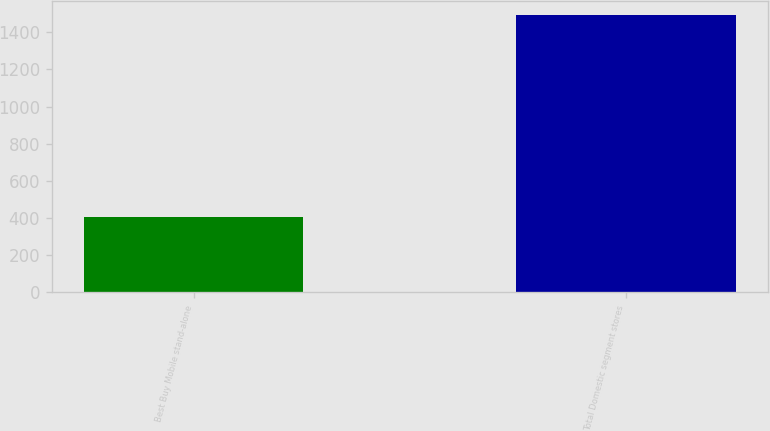Convert chart. <chart><loc_0><loc_0><loc_500><loc_500><bar_chart><fcel>Best Buy Mobile stand-alone<fcel>Total Domestic segment stores<nl><fcel>406<fcel>1495<nl></chart> 